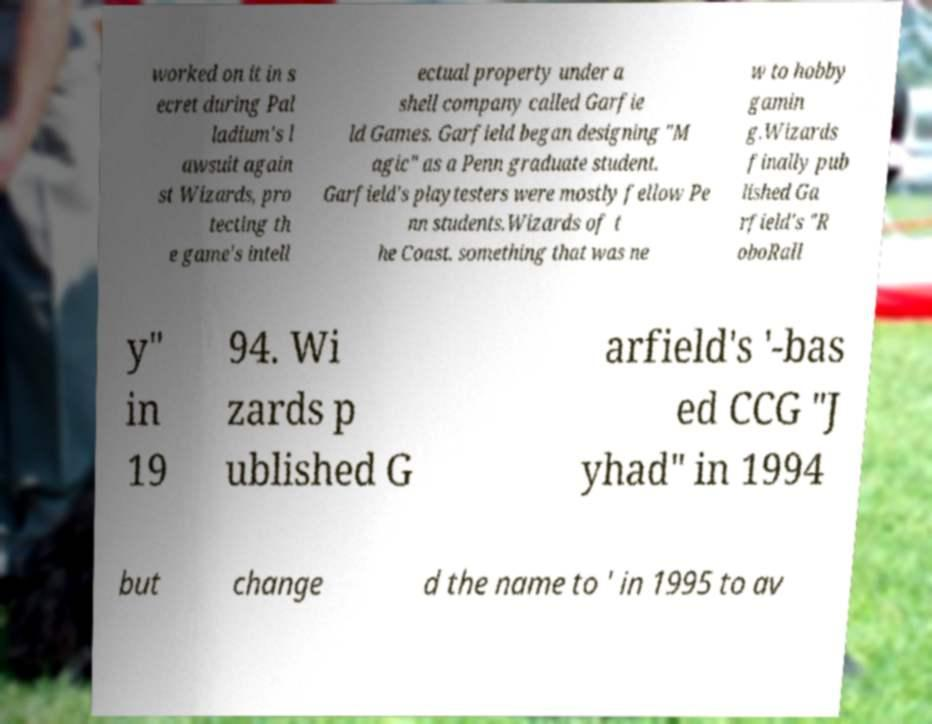Could you extract and type out the text from this image? worked on it in s ecret during Pal ladium's l awsuit again st Wizards, pro tecting th e game's intell ectual property under a shell company called Garfie ld Games. Garfield began designing "M agic" as a Penn graduate student. Garfield's playtesters were mostly fellow Pe nn students.Wizards of t he Coast. something that was ne w to hobby gamin g.Wizards finally pub lished Ga rfield's "R oboRall y" in 19 94. Wi zards p ublished G arfield's '-bas ed CCG "J yhad" in 1994 but change d the name to ' in 1995 to av 